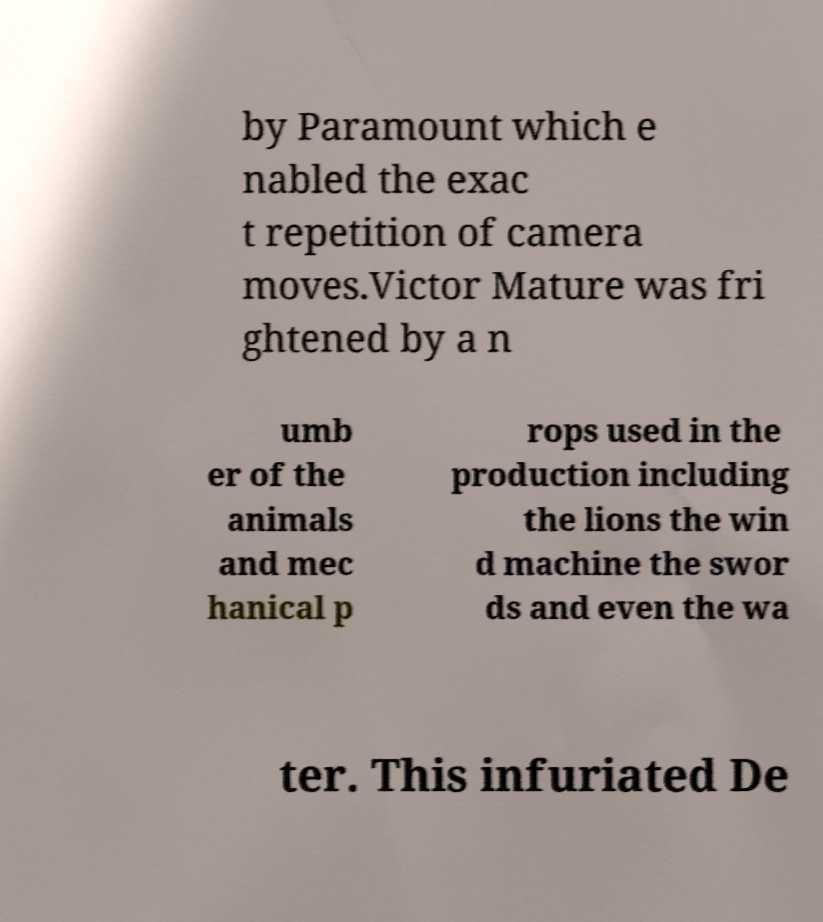There's text embedded in this image that I need extracted. Can you transcribe it verbatim? by Paramount which e nabled the exac t repetition of camera moves.Victor Mature was fri ghtened by a n umb er of the animals and mec hanical p rops used in the production including the lions the win d machine the swor ds and even the wa ter. This infuriated De 